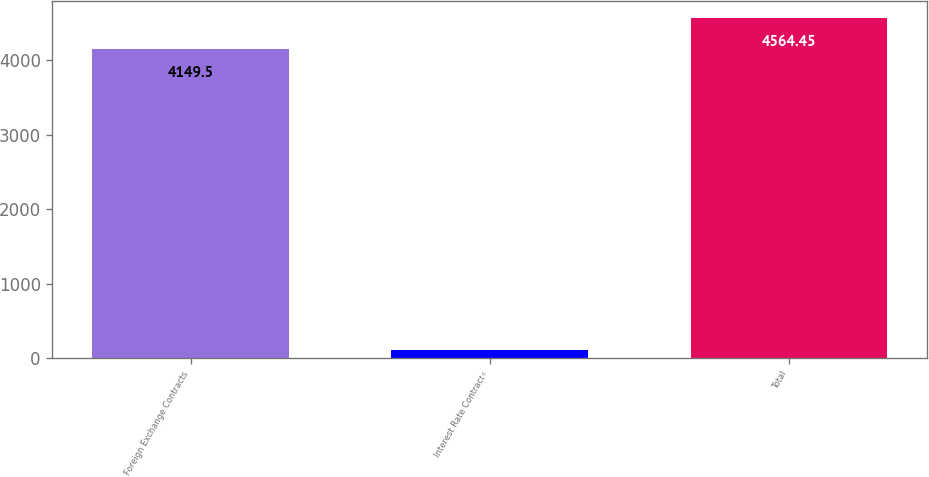Convert chart to OTSL. <chart><loc_0><loc_0><loc_500><loc_500><bar_chart><fcel>Foreign Exchange Contracts<fcel>Interest Rate Contracts<fcel>Total<nl><fcel>4149.5<fcel>105.5<fcel>4564.45<nl></chart> 